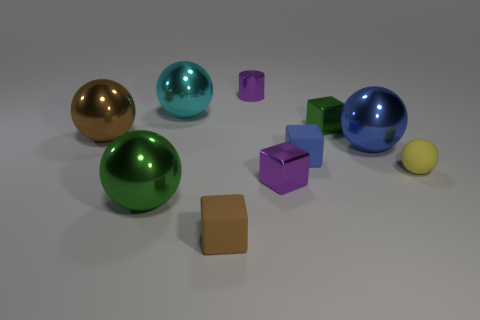Subtract all big cyan balls. How many balls are left? 4 Subtract 2 spheres. How many spheres are left? 3 Subtract all green spheres. How many spheres are left? 4 Subtract all cylinders. How many objects are left? 9 Add 1 green blocks. How many green blocks are left? 2 Add 7 cylinders. How many cylinders exist? 8 Subtract 0 gray balls. How many objects are left? 10 Subtract all yellow cubes. Subtract all cyan cylinders. How many cubes are left? 4 Subtract all green metallic cylinders. Subtract all tiny purple objects. How many objects are left? 8 